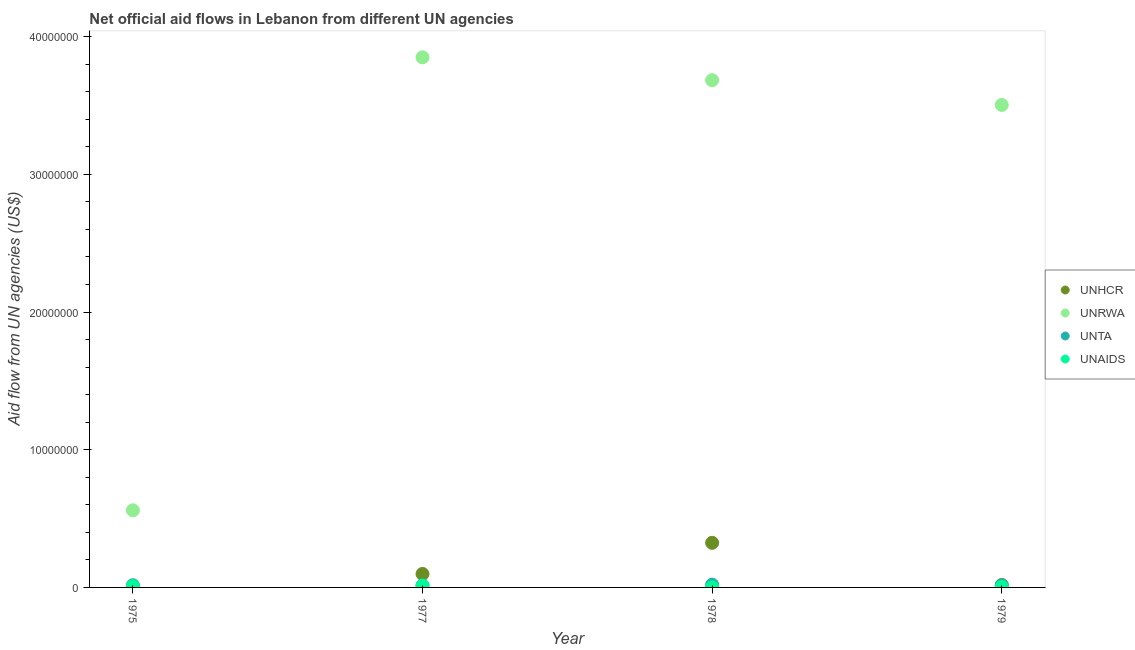How many different coloured dotlines are there?
Keep it short and to the point. 4. What is the amount of aid given by unta in 1979?
Make the answer very short. 1.50e+05. Across all years, what is the maximum amount of aid given by unrwa?
Make the answer very short. 3.85e+07. Across all years, what is the minimum amount of aid given by unta?
Ensure brevity in your answer.  1.50e+05. In which year was the amount of aid given by unhcr minimum?
Your response must be concise. 1975. What is the total amount of aid given by unaids in the graph?
Offer a very short reply. 2.50e+05. What is the difference between the amount of aid given by unhcr in 1975 and that in 1979?
Offer a terse response. -1.30e+05. What is the difference between the amount of aid given by unta in 1978 and the amount of aid given by unrwa in 1977?
Provide a short and direct response. -3.83e+07. What is the average amount of aid given by unhcr per year?
Make the answer very short. 1.11e+06. In the year 1975, what is the difference between the amount of aid given by unta and amount of aid given by unrwa?
Make the answer very short. -5.44e+06. Is the difference between the amount of aid given by unrwa in 1975 and 1977 greater than the difference between the amount of aid given by unaids in 1975 and 1977?
Keep it short and to the point. No. What is the difference between the highest and the second highest amount of aid given by unta?
Ensure brevity in your answer.  4.00e+04. What is the difference between the highest and the lowest amount of aid given by unhcr?
Your response must be concise. 3.19e+06. Is the sum of the amount of aid given by unrwa in 1978 and 1979 greater than the maximum amount of aid given by unhcr across all years?
Provide a succinct answer. Yes. Does the amount of aid given by unaids monotonically increase over the years?
Your answer should be very brief. No. How many dotlines are there?
Keep it short and to the point. 4. Are the values on the major ticks of Y-axis written in scientific E-notation?
Provide a succinct answer. No. Does the graph contain any zero values?
Your answer should be very brief. No. Does the graph contain grids?
Your answer should be compact. No. Where does the legend appear in the graph?
Provide a succinct answer. Center right. How are the legend labels stacked?
Keep it short and to the point. Vertical. What is the title of the graph?
Ensure brevity in your answer.  Net official aid flows in Lebanon from different UN agencies. Does "Ease of arranging shipments" appear as one of the legend labels in the graph?
Make the answer very short. No. What is the label or title of the X-axis?
Make the answer very short. Year. What is the label or title of the Y-axis?
Ensure brevity in your answer.  Aid flow from UN agencies (US$). What is the Aid flow from UN agencies (US$) in UNRWA in 1975?
Provide a short and direct response. 5.60e+06. What is the Aid flow from UN agencies (US$) of UNTA in 1975?
Your answer should be compact. 1.60e+05. What is the Aid flow from UN agencies (US$) in UNHCR in 1977?
Your response must be concise. 9.80e+05. What is the Aid flow from UN agencies (US$) of UNRWA in 1977?
Keep it short and to the point. 3.85e+07. What is the Aid flow from UN agencies (US$) of UNTA in 1977?
Your response must be concise. 1.50e+05. What is the Aid flow from UN agencies (US$) of UNAIDS in 1977?
Your response must be concise. 1.20e+05. What is the Aid flow from UN agencies (US$) of UNHCR in 1978?
Your response must be concise. 3.24e+06. What is the Aid flow from UN agencies (US$) in UNRWA in 1978?
Offer a terse response. 3.68e+07. What is the Aid flow from UN agencies (US$) in UNTA in 1978?
Offer a very short reply. 2.00e+05. What is the Aid flow from UN agencies (US$) of UNAIDS in 1978?
Your answer should be compact. 10000. What is the Aid flow from UN agencies (US$) of UNRWA in 1979?
Your response must be concise. 3.50e+07. Across all years, what is the maximum Aid flow from UN agencies (US$) in UNHCR?
Give a very brief answer. 3.24e+06. Across all years, what is the maximum Aid flow from UN agencies (US$) in UNRWA?
Your answer should be compact. 3.85e+07. Across all years, what is the maximum Aid flow from UN agencies (US$) of UNAIDS?
Keep it short and to the point. 1.20e+05. Across all years, what is the minimum Aid flow from UN agencies (US$) in UNRWA?
Make the answer very short. 5.60e+06. Across all years, what is the minimum Aid flow from UN agencies (US$) in UNTA?
Your response must be concise. 1.50e+05. Across all years, what is the minimum Aid flow from UN agencies (US$) in UNAIDS?
Offer a terse response. 10000. What is the total Aid flow from UN agencies (US$) of UNHCR in the graph?
Your response must be concise. 4.45e+06. What is the total Aid flow from UN agencies (US$) in UNRWA in the graph?
Give a very brief answer. 1.16e+08. What is the total Aid flow from UN agencies (US$) in UNTA in the graph?
Your answer should be very brief. 6.60e+05. What is the total Aid flow from UN agencies (US$) in UNAIDS in the graph?
Provide a short and direct response. 2.50e+05. What is the difference between the Aid flow from UN agencies (US$) in UNHCR in 1975 and that in 1977?
Your answer should be very brief. -9.30e+05. What is the difference between the Aid flow from UN agencies (US$) in UNRWA in 1975 and that in 1977?
Provide a short and direct response. -3.29e+07. What is the difference between the Aid flow from UN agencies (US$) of UNAIDS in 1975 and that in 1977?
Your response must be concise. -4.00e+04. What is the difference between the Aid flow from UN agencies (US$) in UNHCR in 1975 and that in 1978?
Keep it short and to the point. -3.19e+06. What is the difference between the Aid flow from UN agencies (US$) in UNRWA in 1975 and that in 1978?
Provide a succinct answer. -3.12e+07. What is the difference between the Aid flow from UN agencies (US$) in UNRWA in 1975 and that in 1979?
Make the answer very short. -2.94e+07. What is the difference between the Aid flow from UN agencies (US$) in UNTA in 1975 and that in 1979?
Offer a very short reply. 10000. What is the difference between the Aid flow from UN agencies (US$) of UNAIDS in 1975 and that in 1979?
Provide a short and direct response. 4.00e+04. What is the difference between the Aid flow from UN agencies (US$) in UNHCR in 1977 and that in 1978?
Make the answer very short. -2.26e+06. What is the difference between the Aid flow from UN agencies (US$) in UNRWA in 1977 and that in 1978?
Provide a short and direct response. 1.66e+06. What is the difference between the Aid flow from UN agencies (US$) of UNTA in 1977 and that in 1978?
Make the answer very short. -5.00e+04. What is the difference between the Aid flow from UN agencies (US$) of UNRWA in 1977 and that in 1979?
Keep it short and to the point. 3.46e+06. What is the difference between the Aid flow from UN agencies (US$) in UNTA in 1977 and that in 1979?
Make the answer very short. 0. What is the difference between the Aid flow from UN agencies (US$) of UNHCR in 1978 and that in 1979?
Ensure brevity in your answer.  3.06e+06. What is the difference between the Aid flow from UN agencies (US$) in UNRWA in 1978 and that in 1979?
Ensure brevity in your answer.  1.80e+06. What is the difference between the Aid flow from UN agencies (US$) of UNTA in 1978 and that in 1979?
Make the answer very short. 5.00e+04. What is the difference between the Aid flow from UN agencies (US$) of UNHCR in 1975 and the Aid flow from UN agencies (US$) of UNRWA in 1977?
Ensure brevity in your answer.  -3.84e+07. What is the difference between the Aid flow from UN agencies (US$) of UNHCR in 1975 and the Aid flow from UN agencies (US$) of UNTA in 1977?
Give a very brief answer. -1.00e+05. What is the difference between the Aid flow from UN agencies (US$) of UNHCR in 1975 and the Aid flow from UN agencies (US$) of UNAIDS in 1977?
Your response must be concise. -7.00e+04. What is the difference between the Aid flow from UN agencies (US$) in UNRWA in 1975 and the Aid flow from UN agencies (US$) in UNTA in 1977?
Keep it short and to the point. 5.45e+06. What is the difference between the Aid flow from UN agencies (US$) of UNRWA in 1975 and the Aid flow from UN agencies (US$) of UNAIDS in 1977?
Ensure brevity in your answer.  5.48e+06. What is the difference between the Aid flow from UN agencies (US$) of UNHCR in 1975 and the Aid flow from UN agencies (US$) of UNRWA in 1978?
Keep it short and to the point. -3.68e+07. What is the difference between the Aid flow from UN agencies (US$) in UNHCR in 1975 and the Aid flow from UN agencies (US$) in UNTA in 1978?
Ensure brevity in your answer.  -1.50e+05. What is the difference between the Aid flow from UN agencies (US$) of UNHCR in 1975 and the Aid flow from UN agencies (US$) of UNAIDS in 1978?
Your answer should be very brief. 4.00e+04. What is the difference between the Aid flow from UN agencies (US$) in UNRWA in 1975 and the Aid flow from UN agencies (US$) in UNTA in 1978?
Make the answer very short. 5.40e+06. What is the difference between the Aid flow from UN agencies (US$) of UNRWA in 1975 and the Aid flow from UN agencies (US$) of UNAIDS in 1978?
Offer a terse response. 5.59e+06. What is the difference between the Aid flow from UN agencies (US$) in UNHCR in 1975 and the Aid flow from UN agencies (US$) in UNRWA in 1979?
Offer a terse response. -3.50e+07. What is the difference between the Aid flow from UN agencies (US$) in UNHCR in 1975 and the Aid flow from UN agencies (US$) in UNTA in 1979?
Offer a terse response. -1.00e+05. What is the difference between the Aid flow from UN agencies (US$) in UNRWA in 1975 and the Aid flow from UN agencies (US$) in UNTA in 1979?
Provide a short and direct response. 5.45e+06. What is the difference between the Aid flow from UN agencies (US$) of UNRWA in 1975 and the Aid flow from UN agencies (US$) of UNAIDS in 1979?
Keep it short and to the point. 5.56e+06. What is the difference between the Aid flow from UN agencies (US$) in UNTA in 1975 and the Aid flow from UN agencies (US$) in UNAIDS in 1979?
Provide a succinct answer. 1.20e+05. What is the difference between the Aid flow from UN agencies (US$) of UNHCR in 1977 and the Aid flow from UN agencies (US$) of UNRWA in 1978?
Offer a terse response. -3.59e+07. What is the difference between the Aid flow from UN agencies (US$) of UNHCR in 1977 and the Aid flow from UN agencies (US$) of UNTA in 1978?
Provide a succinct answer. 7.80e+05. What is the difference between the Aid flow from UN agencies (US$) in UNHCR in 1977 and the Aid flow from UN agencies (US$) in UNAIDS in 1978?
Give a very brief answer. 9.70e+05. What is the difference between the Aid flow from UN agencies (US$) in UNRWA in 1977 and the Aid flow from UN agencies (US$) in UNTA in 1978?
Provide a succinct answer. 3.83e+07. What is the difference between the Aid flow from UN agencies (US$) in UNRWA in 1977 and the Aid flow from UN agencies (US$) in UNAIDS in 1978?
Provide a succinct answer. 3.85e+07. What is the difference between the Aid flow from UN agencies (US$) of UNHCR in 1977 and the Aid flow from UN agencies (US$) of UNRWA in 1979?
Provide a short and direct response. -3.41e+07. What is the difference between the Aid flow from UN agencies (US$) in UNHCR in 1977 and the Aid flow from UN agencies (US$) in UNTA in 1979?
Provide a succinct answer. 8.30e+05. What is the difference between the Aid flow from UN agencies (US$) in UNHCR in 1977 and the Aid flow from UN agencies (US$) in UNAIDS in 1979?
Provide a short and direct response. 9.40e+05. What is the difference between the Aid flow from UN agencies (US$) in UNRWA in 1977 and the Aid flow from UN agencies (US$) in UNTA in 1979?
Provide a short and direct response. 3.84e+07. What is the difference between the Aid flow from UN agencies (US$) in UNRWA in 1977 and the Aid flow from UN agencies (US$) in UNAIDS in 1979?
Ensure brevity in your answer.  3.85e+07. What is the difference between the Aid flow from UN agencies (US$) of UNTA in 1977 and the Aid flow from UN agencies (US$) of UNAIDS in 1979?
Offer a terse response. 1.10e+05. What is the difference between the Aid flow from UN agencies (US$) in UNHCR in 1978 and the Aid flow from UN agencies (US$) in UNRWA in 1979?
Make the answer very short. -3.18e+07. What is the difference between the Aid flow from UN agencies (US$) of UNHCR in 1978 and the Aid flow from UN agencies (US$) of UNTA in 1979?
Your answer should be very brief. 3.09e+06. What is the difference between the Aid flow from UN agencies (US$) in UNHCR in 1978 and the Aid flow from UN agencies (US$) in UNAIDS in 1979?
Your response must be concise. 3.20e+06. What is the difference between the Aid flow from UN agencies (US$) of UNRWA in 1978 and the Aid flow from UN agencies (US$) of UNTA in 1979?
Make the answer very short. 3.67e+07. What is the difference between the Aid flow from UN agencies (US$) in UNRWA in 1978 and the Aid flow from UN agencies (US$) in UNAIDS in 1979?
Provide a short and direct response. 3.68e+07. What is the difference between the Aid flow from UN agencies (US$) of UNTA in 1978 and the Aid flow from UN agencies (US$) of UNAIDS in 1979?
Make the answer very short. 1.60e+05. What is the average Aid flow from UN agencies (US$) in UNHCR per year?
Your answer should be very brief. 1.11e+06. What is the average Aid flow from UN agencies (US$) in UNRWA per year?
Give a very brief answer. 2.90e+07. What is the average Aid flow from UN agencies (US$) of UNTA per year?
Make the answer very short. 1.65e+05. What is the average Aid flow from UN agencies (US$) in UNAIDS per year?
Offer a terse response. 6.25e+04. In the year 1975, what is the difference between the Aid flow from UN agencies (US$) in UNHCR and Aid flow from UN agencies (US$) in UNRWA?
Offer a very short reply. -5.55e+06. In the year 1975, what is the difference between the Aid flow from UN agencies (US$) in UNHCR and Aid flow from UN agencies (US$) in UNTA?
Give a very brief answer. -1.10e+05. In the year 1975, what is the difference between the Aid flow from UN agencies (US$) of UNRWA and Aid flow from UN agencies (US$) of UNTA?
Your response must be concise. 5.44e+06. In the year 1975, what is the difference between the Aid flow from UN agencies (US$) of UNRWA and Aid flow from UN agencies (US$) of UNAIDS?
Make the answer very short. 5.52e+06. In the year 1975, what is the difference between the Aid flow from UN agencies (US$) of UNTA and Aid flow from UN agencies (US$) of UNAIDS?
Ensure brevity in your answer.  8.00e+04. In the year 1977, what is the difference between the Aid flow from UN agencies (US$) in UNHCR and Aid flow from UN agencies (US$) in UNRWA?
Give a very brief answer. -3.75e+07. In the year 1977, what is the difference between the Aid flow from UN agencies (US$) of UNHCR and Aid flow from UN agencies (US$) of UNTA?
Offer a very short reply. 8.30e+05. In the year 1977, what is the difference between the Aid flow from UN agencies (US$) of UNHCR and Aid flow from UN agencies (US$) of UNAIDS?
Offer a very short reply. 8.60e+05. In the year 1977, what is the difference between the Aid flow from UN agencies (US$) in UNRWA and Aid flow from UN agencies (US$) in UNTA?
Make the answer very short. 3.84e+07. In the year 1977, what is the difference between the Aid flow from UN agencies (US$) of UNRWA and Aid flow from UN agencies (US$) of UNAIDS?
Give a very brief answer. 3.84e+07. In the year 1978, what is the difference between the Aid flow from UN agencies (US$) in UNHCR and Aid flow from UN agencies (US$) in UNRWA?
Give a very brief answer. -3.36e+07. In the year 1978, what is the difference between the Aid flow from UN agencies (US$) in UNHCR and Aid flow from UN agencies (US$) in UNTA?
Your response must be concise. 3.04e+06. In the year 1978, what is the difference between the Aid flow from UN agencies (US$) of UNHCR and Aid flow from UN agencies (US$) of UNAIDS?
Offer a terse response. 3.23e+06. In the year 1978, what is the difference between the Aid flow from UN agencies (US$) of UNRWA and Aid flow from UN agencies (US$) of UNTA?
Provide a succinct answer. 3.66e+07. In the year 1978, what is the difference between the Aid flow from UN agencies (US$) in UNRWA and Aid flow from UN agencies (US$) in UNAIDS?
Offer a terse response. 3.68e+07. In the year 1978, what is the difference between the Aid flow from UN agencies (US$) of UNTA and Aid flow from UN agencies (US$) of UNAIDS?
Give a very brief answer. 1.90e+05. In the year 1979, what is the difference between the Aid flow from UN agencies (US$) in UNHCR and Aid flow from UN agencies (US$) in UNRWA?
Offer a very short reply. -3.49e+07. In the year 1979, what is the difference between the Aid flow from UN agencies (US$) of UNHCR and Aid flow from UN agencies (US$) of UNTA?
Offer a terse response. 3.00e+04. In the year 1979, what is the difference between the Aid flow from UN agencies (US$) in UNRWA and Aid flow from UN agencies (US$) in UNTA?
Your answer should be very brief. 3.49e+07. In the year 1979, what is the difference between the Aid flow from UN agencies (US$) in UNRWA and Aid flow from UN agencies (US$) in UNAIDS?
Make the answer very short. 3.50e+07. In the year 1979, what is the difference between the Aid flow from UN agencies (US$) in UNTA and Aid flow from UN agencies (US$) in UNAIDS?
Provide a short and direct response. 1.10e+05. What is the ratio of the Aid flow from UN agencies (US$) of UNHCR in 1975 to that in 1977?
Offer a terse response. 0.05. What is the ratio of the Aid flow from UN agencies (US$) in UNRWA in 1975 to that in 1977?
Your answer should be compact. 0.15. What is the ratio of the Aid flow from UN agencies (US$) of UNTA in 1975 to that in 1977?
Your answer should be very brief. 1.07. What is the ratio of the Aid flow from UN agencies (US$) in UNAIDS in 1975 to that in 1977?
Offer a terse response. 0.67. What is the ratio of the Aid flow from UN agencies (US$) in UNHCR in 1975 to that in 1978?
Offer a terse response. 0.02. What is the ratio of the Aid flow from UN agencies (US$) in UNRWA in 1975 to that in 1978?
Provide a succinct answer. 0.15. What is the ratio of the Aid flow from UN agencies (US$) of UNTA in 1975 to that in 1978?
Keep it short and to the point. 0.8. What is the ratio of the Aid flow from UN agencies (US$) in UNAIDS in 1975 to that in 1978?
Offer a terse response. 8. What is the ratio of the Aid flow from UN agencies (US$) of UNHCR in 1975 to that in 1979?
Your answer should be very brief. 0.28. What is the ratio of the Aid flow from UN agencies (US$) in UNRWA in 1975 to that in 1979?
Keep it short and to the point. 0.16. What is the ratio of the Aid flow from UN agencies (US$) in UNTA in 1975 to that in 1979?
Your answer should be very brief. 1.07. What is the ratio of the Aid flow from UN agencies (US$) of UNHCR in 1977 to that in 1978?
Ensure brevity in your answer.  0.3. What is the ratio of the Aid flow from UN agencies (US$) in UNRWA in 1977 to that in 1978?
Ensure brevity in your answer.  1.05. What is the ratio of the Aid flow from UN agencies (US$) in UNAIDS in 1977 to that in 1978?
Offer a very short reply. 12. What is the ratio of the Aid flow from UN agencies (US$) in UNHCR in 1977 to that in 1979?
Provide a succinct answer. 5.44. What is the ratio of the Aid flow from UN agencies (US$) of UNRWA in 1977 to that in 1979?
Offer a very short reply. 1.1. What is the ratio of the Aid flow from UN agencies (US$) of UNTA in 1977 to that in 1979?
Keep it short and to the point. 1. What is the ratio of the Aid flow from UN agencies (US$) of UNRWA in 1978 to that in 1979?
Make the answer very short. 1.05. What is the ratio of the Aid flow from UN agencies (US$) of UNAIDS in 1978 to that in 1979?
Ensure brevity in your answer.  0.25. What is the difference between the highest and the second highest Aid flow from UN agencies (US$) in UNHCR?
Ensure brevity in your answer.  2.26e+06. What is the difference between the highest and the second highest Aid flow from UN agencies (US$) of UNRWA?
Make the answer very short. 1.66e+06. What is the difference between the highest and the second highest Aid flow from UN agencies (US$) in UNTA?
Provide a short and direct response. 4.00e+04. What is the difference between the highest and the second highest Aid flow from UN agencies (US$) in UNAIDS?
Offer a very short reply. 4.00e+04. What is the difference between the highest and the lowest Aid flow from UN agencies (US$) in UNHCR?
Make the answer very short. 3.19e+06. What is the difference between the highest and the lowest Aid flow from UN agencies (US$) in UNRWA?
Your answer should be compact. 3.29e+07. What is the difference between the highest and the lowest Aid flow from UN agencies (US$) in UNAIDS?
Your answer should be very brief. 1.10e+05. 